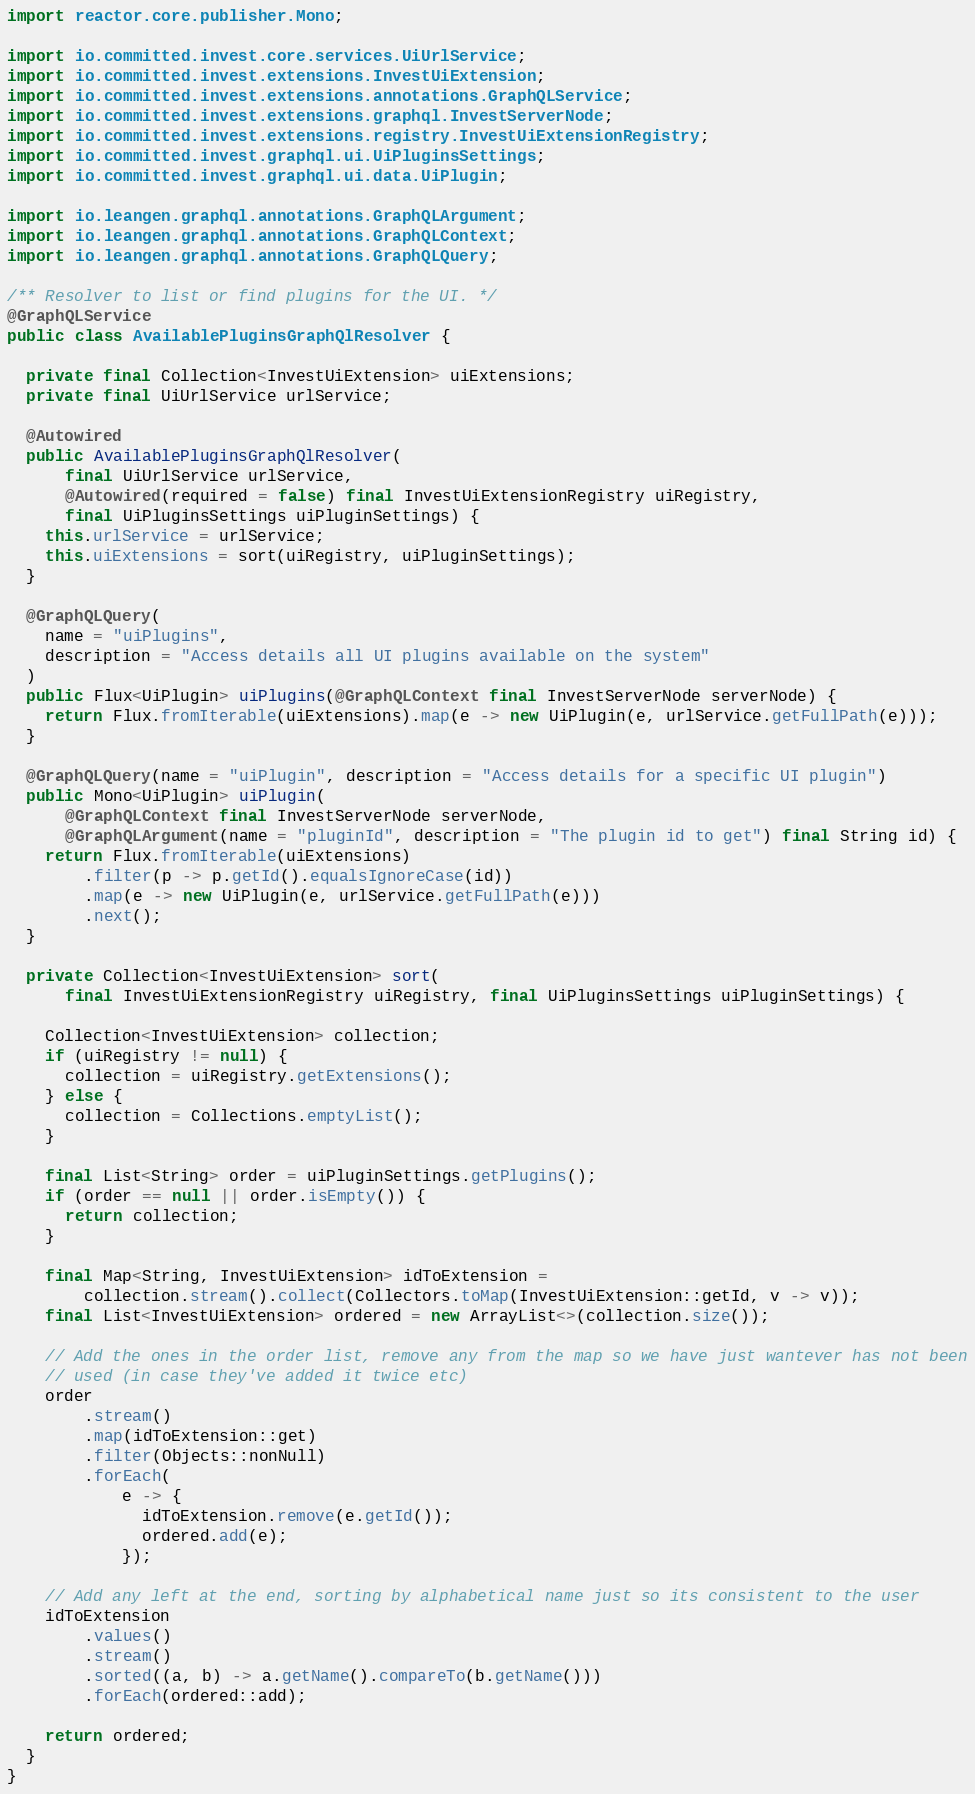Convert code to text. <code><loc_0><loc_0><loc_500><loc_500><_Java_>import reactor.core.publisher.Mono;

import io.committed.invest.core.services.UiUrlService;
import io.committed.invest.extensions.InvestUiExtension;
import io.committed.invest.extensions.annotations.GraphQLService;
import io.committed.invest.extensions.graphql.InvestServerNode;
import io.committed.invest.extensions.registry.InvestUiExtensionRegistry;
import io.committed.invest.graphql.ui.UiPluginsSettings;
import io.committed.invest.graphql.ui.data.UiPlugin;

import io.leangen.graphql.annotations.GraphQLArgument;
import io.leangen.graphql.annotations.GraphQLContext;
import io.leangen.graphql.annotations.GraphQLQuery;

/** Resolver to list or find plugins for the UI. */
@GraphQLService
public class AvailablePluginsGraphQlResolver {

  private final Collection<InvestUiExtension> uiExtensions;
  private final UiUrlService urlService;

  @Autowired
  public AvailablePluginsGraphQlResolver(
      final UiUrlService urlService,
      @Autowired(required = false) final InvestUiExtensionRegistry uiRegistry,
      final UiPluginsSettings uiPluginSettings) {
    this.urlService = urlService;
    this.uiExtensions = sort(uiRegistry, uiPluginSettings);
  }

  @GraphQLQuery(
    name = "uiPlugins",
    description = "Access details all UI plugins available on the system"
  )
  public Flux<UiPlugin> uiPlugins(@GraphQLContext final InvestServerNode serverNode) {
    return Flux.fromIterable(uiExtensions).map(e -> new UiPlugin(e, urlService.getFullPath(e)));
  }

  @GraphQLQuery(name = "uiPlugin", description = "Access details for a specific UI plugin")
  public Mono<UiPlugin> uiPlugin(
      @GraphQLContext final InvestServerNode serverNode,
      @GraphQLArgument(name = "pluginId", description = "The plugin id to get") final String id) {
    return Flux.fromIterable(uiExtensions)
        .filter(p -> p.getId().equalsIgnoreCase(id))
        .map(e -> new UiPlugin(e, urlService.getFullPath(e)))
        .next();
  }

  private Collection<InvestUiExtension> sort(
      final InvestUiExtensionRegistry uiRegistry, final UiPluginsSettings uiPluginSettings) {

    Collection<InvestUiExtension> collection;
    if (uiRegistry != null) {
      collection = uiRegistry.getExtensions();
    } else {
      collection = Collections.emptyList();
    }

    final List<String> order = uiPluginSettings.getPlugins();
    if (order == null || order.isEmpty()) {
      return collection;
    }

    final Map<String, InvestUiExtension> idToExtension =
        collection.stream().collect(Collectors.toMap(InvestUiExtension::getId, v -> v));
    final List<InvestUiExtension> ordered = new ArrayList<>(collection.size());

    // Add the ones in the order list, remove any from the map so we have just wantever has not been
    // used (in case they've added it twice etc)
    order
        .stream()
        .map(idToExtension::get)
        .filter(Objects::nonNull)
        .forEach(
            e -> {
              idToExtension.remove(e.getId());
              ordered.add(e);
            });

    // Add any left at the end, sorting by alphabetical name just so its consistent to the user
    idToExtension
        .values()
        .stream()
        .sorted((a, b) -> a.getName().compareTo(b.getName()))
        .forEach(ordered::add);

    return ordered;
  }
}
</code> 